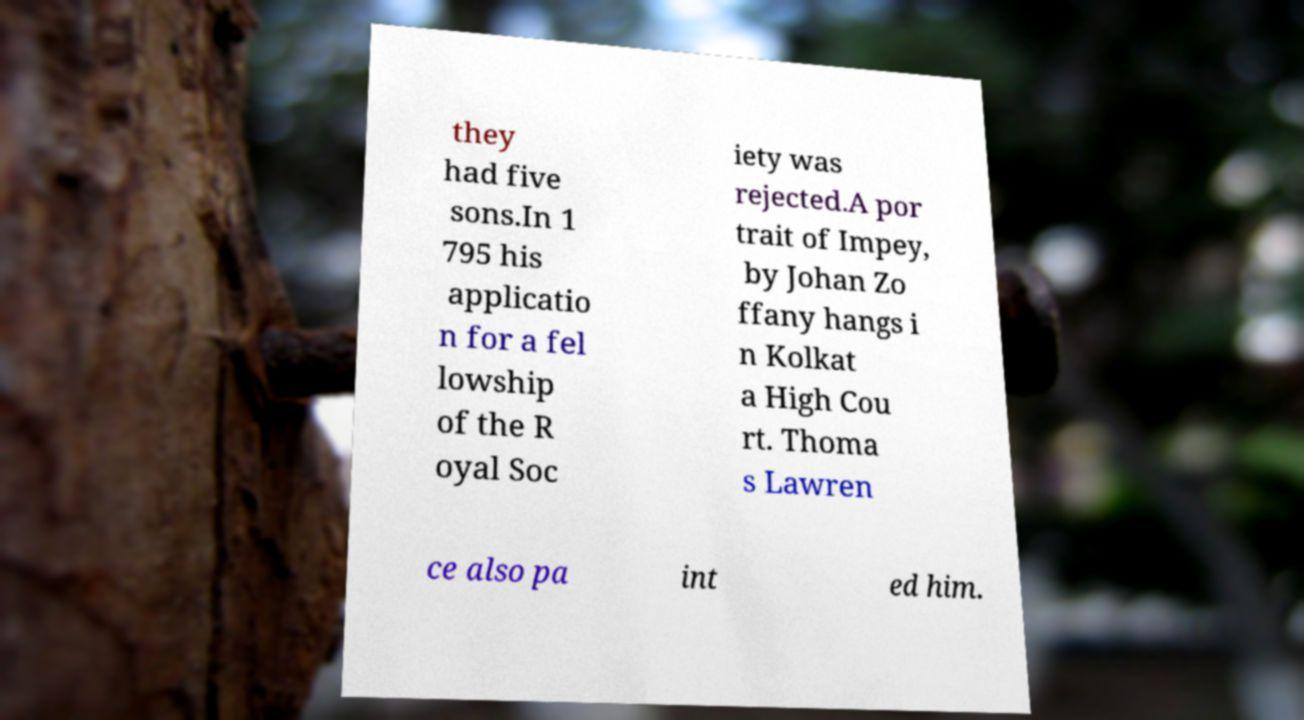There's text embedded in this image that I need extracted. Can you transcribe it verbatim? they had five sons.In 1 795 his applicatio n for a fel lowship of the R oyal Soc iety was rejected.A por trait of Impey, by Johan Zo ffany hangs i n Kolkat a High Cou rt. Thoma s Lawren ce also pa int ed him. 